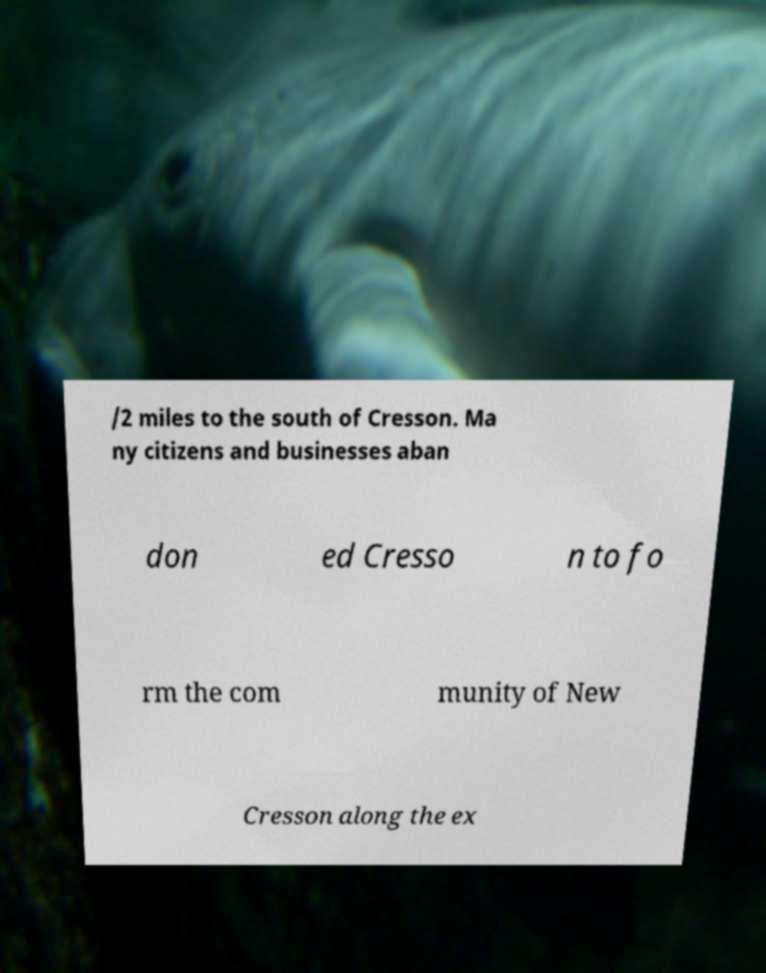Could you assist in decoding the text presented in this image and type it out clearly? /2 miles to the south of Cresson. Ma ny citizens and businesses aban don ed Cresso n to fo rm the com munity of New Cresson along the ex 